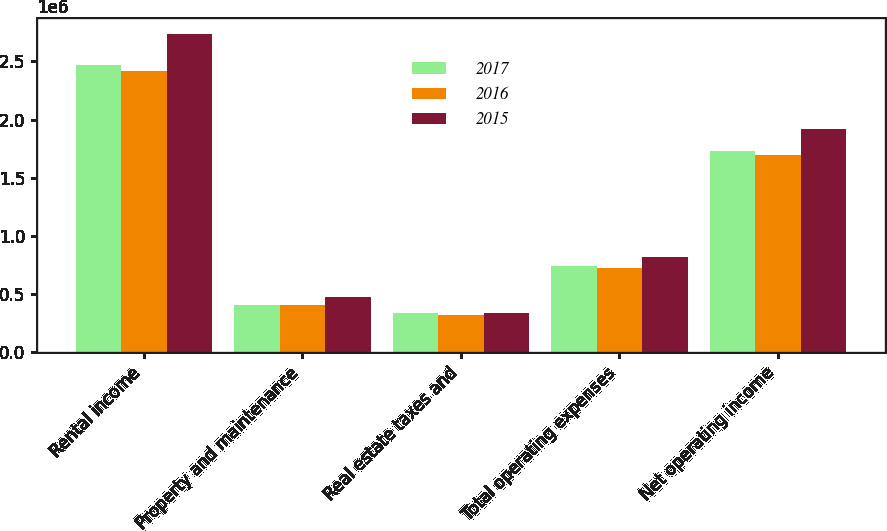Convert chart. <chart><loc_0><loc_0><loc_500><loc_500><stacked_bar_chart><ecel><fcel>Rental income<fcel>Property and maintenance<fcel>Real estate taxes and<fcel>Total operating expenses<fcel>Net operating income<nl><fcel>2017<fcel>2.47069e+06<fcel>405281<fcel>335495<fcel>740776<fcel>1.72991e+06<nl><fcel>2016<fcel>2.42223e+06<fcel>406823<fcel>317387<fcel>724210<fcel>1.69802e+06<nl><fcel>2015<fcel>2.73658e+06<fcel>479160<fcel>339802<fcel>818962<fcel>1.91762e+06<nl></chart> 